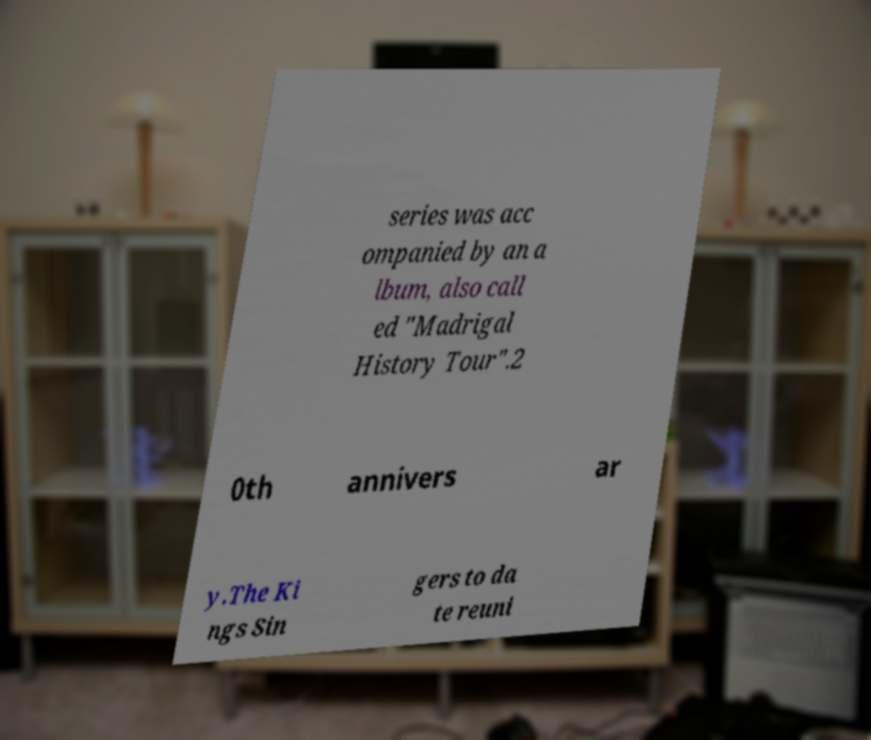There's text embedded in this image that I need extracted. Can you transcribe it verbatim? series was acc ompanied by an a lbum, also call ed "Madrigal History Tour".2 0th annivers ar y.The Ki ngs Sin gers to da te reuni 